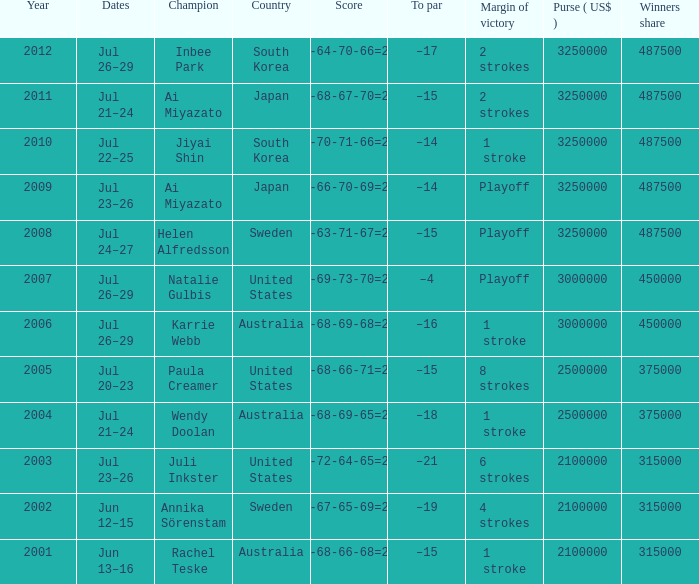What is the smallest year indicated? 2001.0. 